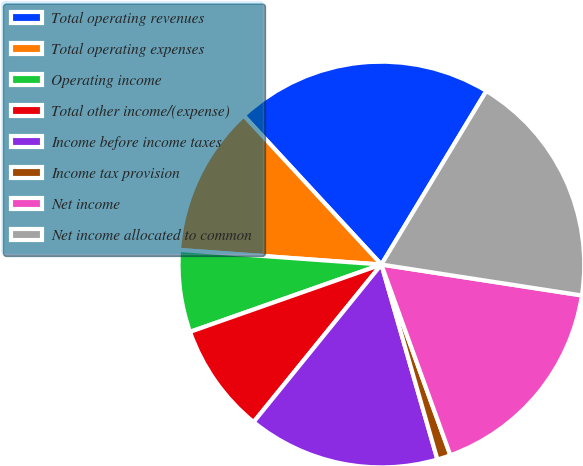Convert chart. <chart><loc_0><loc_0><loc_500><loc_500><pie_chart><fcel>Total operating revenues<fcel>Total operating expenses<fcel>Operating income<fcel>Total other income/(expense)<fcel>Income before income taxes<fcel>Income tax provision<fcel>Net income<fcel>Net income allocated to common<nl><fcel>20.53%<fcel>11.98%<fcel>6.53%<fcel>8.77%<fcel>15.3%<fcel>1.07%<fcel>17.04%<fcel>18.78%<nl></chart> 